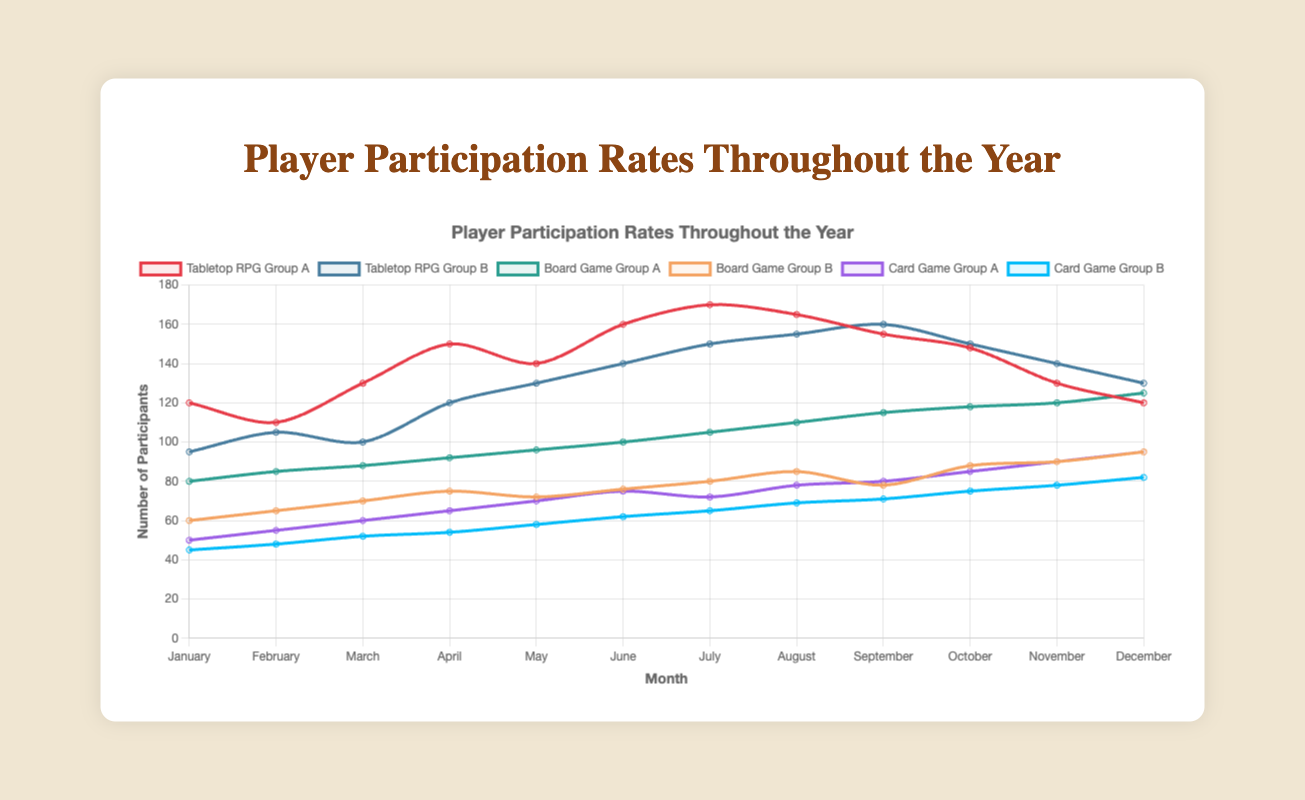Which group had the highest participation in August? Looking at the August data, Tabletop RPG Group A had 165 participants, which is the highest among all groups.
Answer: Tabletop RPG Group A Compare the participation rate of Card Game Group B in January and December. In January, Card Game Group B had 45 participants, while in December it had 82 participants. Comparing these numbers, participation increased from January to December.
Answer: Increased Which group consistently increased their participation from January to December? Analyzing the trends from January to December, Board Game Group A shows a consistent increase in participation month-over-month from 80 to 125 participants.
Answer: Board Game Group A What is the total participation for Tabletop RPG Group B in the first quarter of the year (January to March)? Summing up the values for January (95), February (105), and March (100) gives 95 + 105 + 100 = 300.
Answer: 300 Find the months where Board Game Group B had higher participation than Card Game Group A. Examining the data for each month, Board Game Group B had higher participation in September (78 vs. 80), October (88 vs. 85), November (90 vs. 90), and December (95 vs. 95). Note that September and November had higher participation, October and December had equal participation.
Answer: September, October, November, December What's the difference in participation between Board Game Group A and Board Game Group B in June? Board Game Group A had 100 participants in June, whereas Board Game Group B had 76. The difference is 100 - 76 = 24.
Answer: 24 During which month did Card Game Group A first surpass 80 participants? Card Game Group A first surpassed 80 participants in September with 80 participants.
Answer: September What is the average monthly participation for Tabletop RPG Group A over the year? Adding up all monthly values (120 + 110 + 130 + 150 + 140 + 160 + 170 + 165 + 155 + 148 + 130 + 120) gives 1698. Dividing this by 12 (number of months) results in 1698 / 12 ≈ 141.5.
Answer: 141.5 